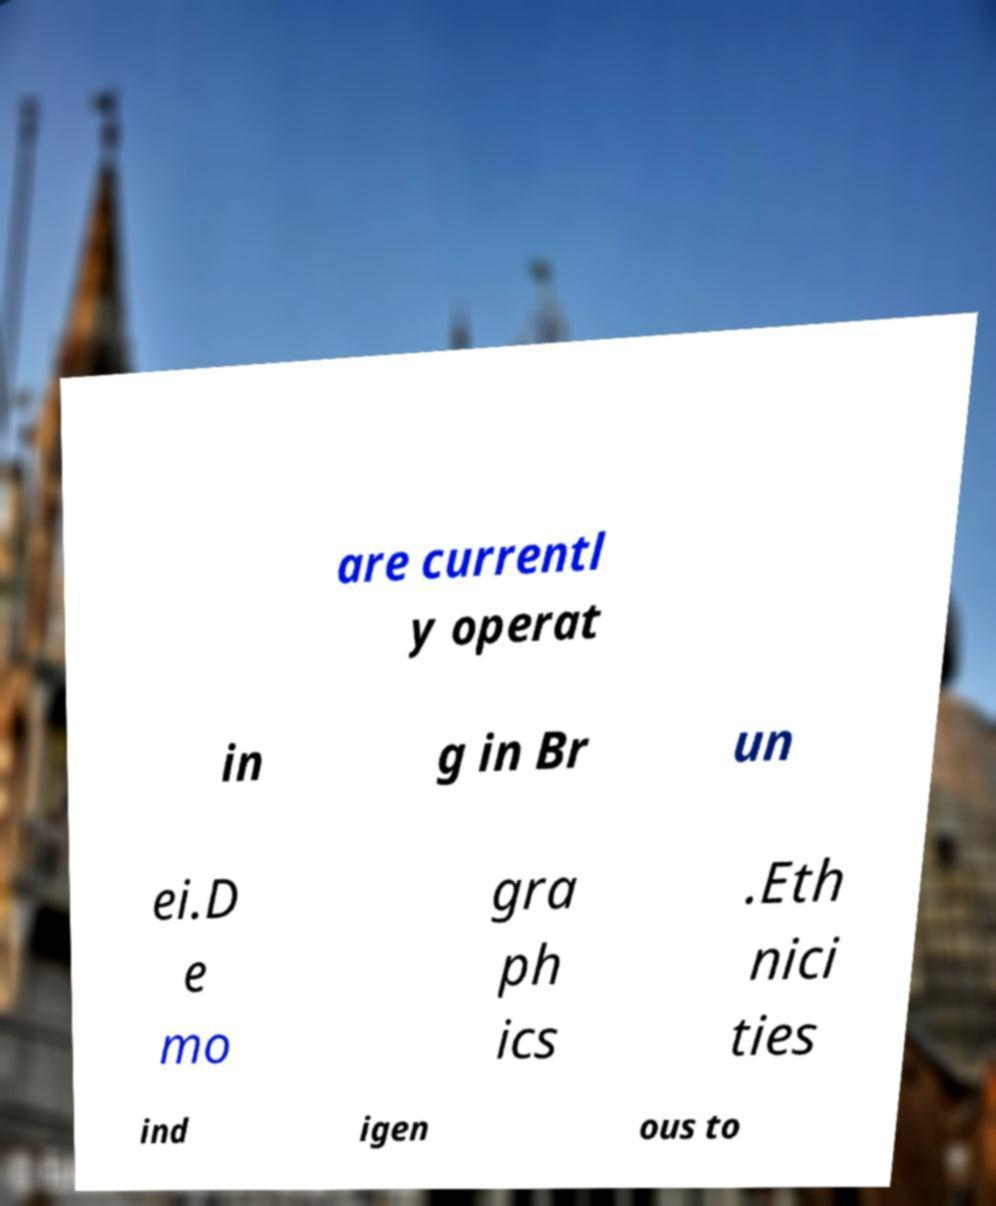What messages or text are displayed in this image? I need them in a readable, typed format. are currentl y operat in g in Br un ei.D e mo gra ph ics .Eth nici ties ind igen ous to 